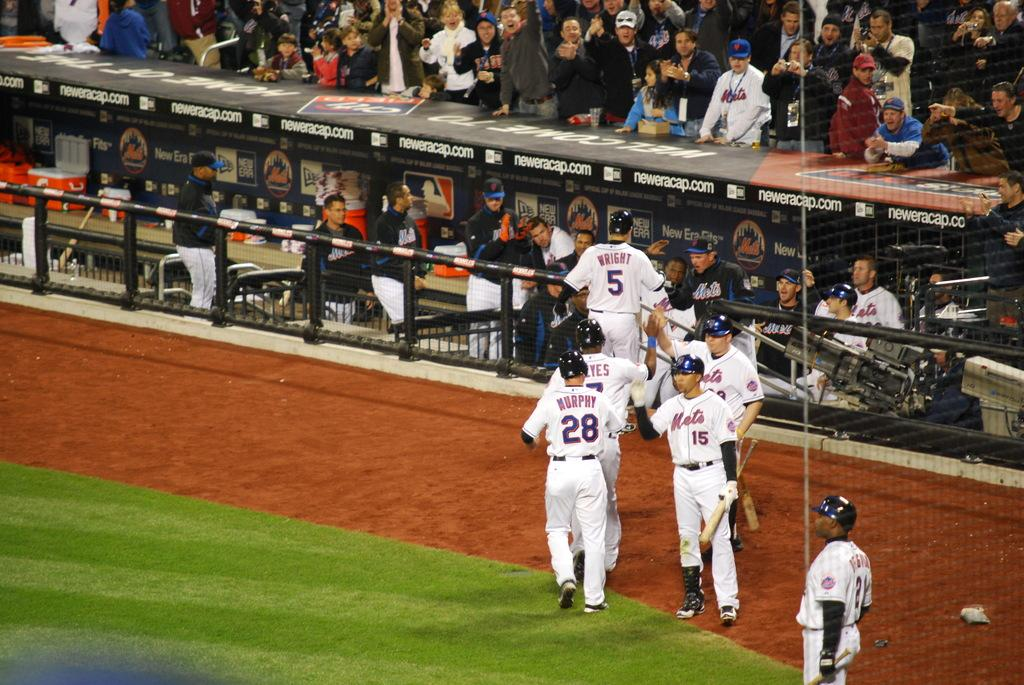<image>
Summarize the visual content of the image. A baseball team wearing white uniform with numbers 28, 5 and 15 are walking in the side of the field. 